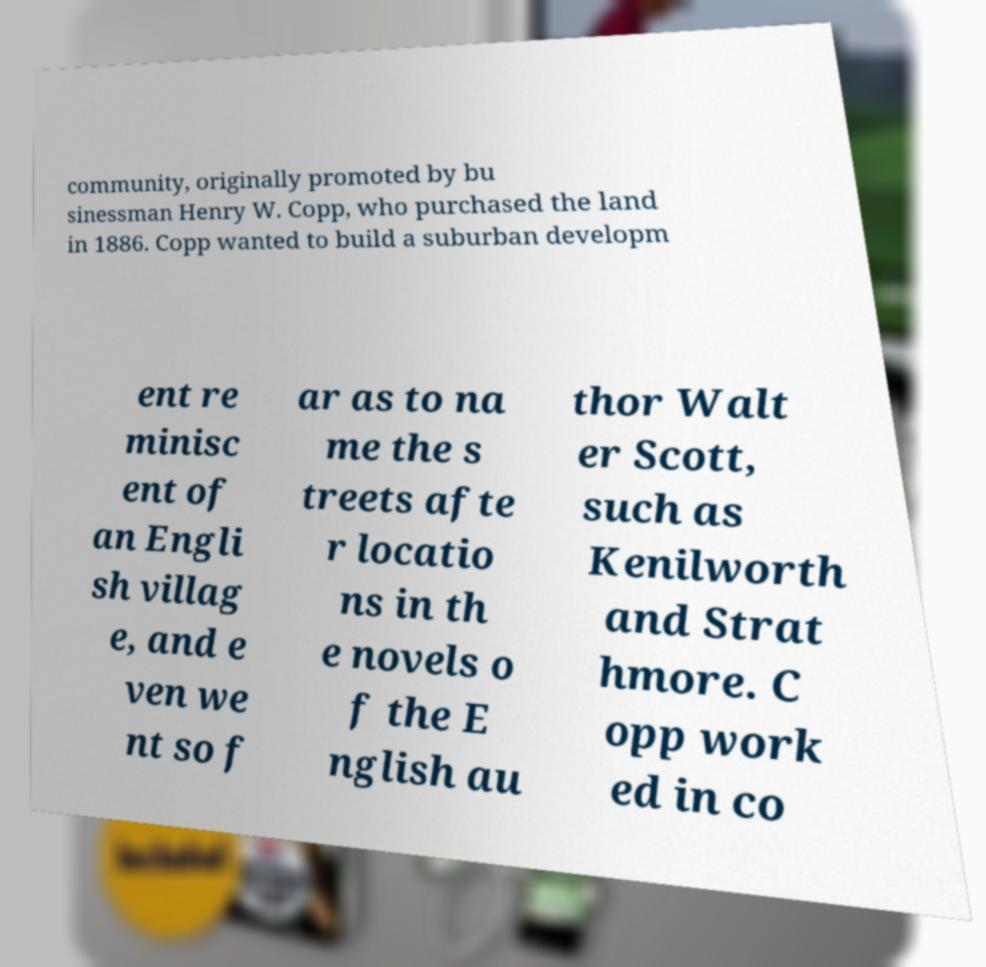Please read and relay the text visible in this image. What does it say? community, originally promoted by bu sinessman Henry W. Copp, who purchased the land in 1886. Copp wanted to build a suburban developm ent re minisc ent of an Engli sh villag e, and e ven we nt so f ar as to na me the s treets afte r locatio ns in th e novels o f the E nglish au thor Walt er Scott, such as Kenilworth and Strat hmore. C opp work ed in co 